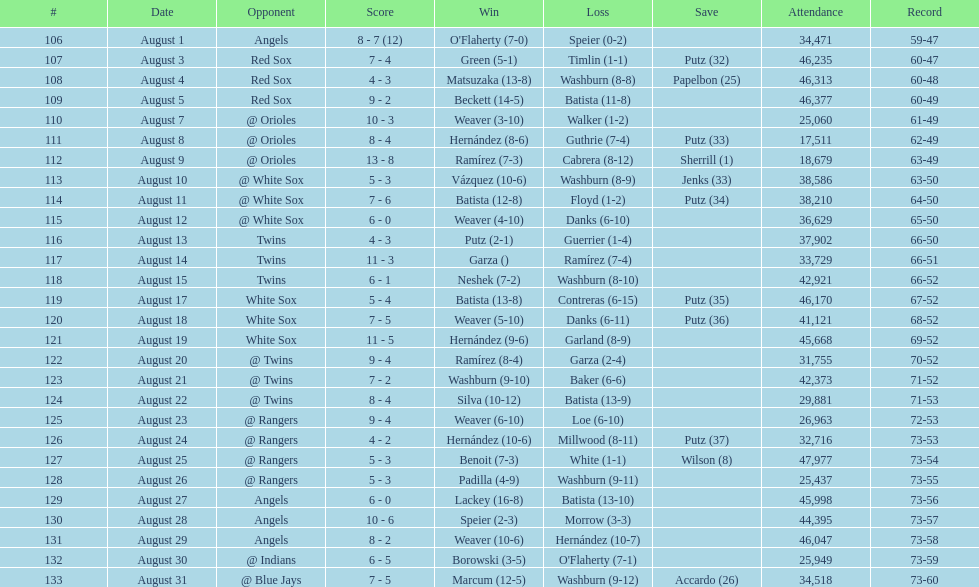Maximum run gap 8. Would you be able to parse every entry in this table? {'header': ['#', 'Date', 'Opponent', 'Score', 'Win', 'Loss', 'Save', 'Attendance', 'Record'], 'rows': [['106', 'August 1', 'Angels', '8 - 7 (12)', "O'Flaherty (7-0)", 'Speier (0-2)', '', '34,471', '59-47'], ['107', 'August 3', 'Red Sox', '7 - 4', 'Green (5-1)', 'Timlin (1-1)', 'Putz (32)', '46,235', '60-47'], ['108', 'August 4', 'Red Sox', '4 - 3', 'Matsuzaka (13-8)', 'Washburn (8-8)', 'Papelbon (25)', '46,313', '60-48'], ['109', 'August 5', 'Red Sox', '9 - 2', 'Beckett (14-5)', 'Batista (11-8)', '', '46,377', '60-49'], ['110', 'August 7', '@ Orioles', '10 - 3', 'Weaver (3-10)', 'Walker (1-2)', '', '25,060', '61-49'], ['111', 'August 8', '@ Orioles', '8 - 4', 'Hernández (8-6)', 'Guthrie (7-4)', 'Putz (33)', '17,511', '62-49'], ['112', 'August 9', '@ Orioles', '13 - 8', 'Ramírez (7-3)', 'Cabrera (8-12)', 'Sherrill (1)', '18,679', '63-49'], ['113', 'August 10', '@ White Sox', '5 - 3', 'Vázquez (10-6)', 'Washburn (8-9)', 'Jenks (33)', '38,586', '63-50'], ['114', 'August 11', '@ White Sox', '7 - 6', 'Batista (12-8)', 'Floyd (1-2)', 'Putz (34)', '38,210', '64-50'], ['115', 'August 12', '@ White Sox', '6 - 0', 'Weaver (4-10)', 'Danks (6-10)', '', '36,629', '65-50'], ['116', 'August 13', 'Twins', '4 - 3', 'Putz (2-1)', 'Guerrier (1-4)', '', '37,902', '66-50'], ['117', 'August 14', 'Twins', '11 - 3', 'Garza ()', 'Ramírez (7-4)', '', '33,729', '66-51'], ['118', 'August 15', 'Twins', '6 - 1', 'Neshek (7-2)', 'Washburn (8-10)', '', '42,921', '66-52'], ['119', 'August 17', 'White Sox', '5 - 4', 'Batista (13-8)', 'Contreras (6-15)', 'Putz (35)', '46,170', '67-52'], ['120', 'August 18', 'White Sox', '7 - 5', 'Weaver (5-10)', 'Danks (6-11)', 'Putz (36)', '41,121', '68-52'], ['121', 'August 19', 'White Sox', '11 - 5', 'Hernández (9-6)', 'Garland (8-9)', '', '45,668', '69-52'], ['122', 'August 20', '@ Twins', '9 - 4', 'Ramírez (8-4)', 'Garza (2-4)', '', '31,755', '70-52'], ['123', 'August 21', '@ Twins', '7 - 2', 'Washburn (9-10)', 'Baker (6-6)', '', '42,373', '71-52'], ['124', 'August 22', '@ Twins', '8 - 4', 'Silva (10-12)', 'Batista (13-9)', '', '29,881', '71-53'], ['125', 'August 23', '@ Rangers', '9 - 4', 'Weaver (6-10)', 'Loe (6-10)', '', '26,963', '72-53'], ['126', 'August 24', '@ Rangers', '4 - 2', 'Hernández (10-6)', 'Millwood (8-11)', 'Putz (37)', '32,716', '73-53'], ['127', 'August 25', '@ Rangers', '5 - 3', 'Benoit (7-3)', 'White (1-1)', 'Wilson (8)', '47,977', '73-54'], ['128', 'August 26', '@ Rangers', '5 - 3', 'Padilla (4-9)', 'Washburn (9-11)', '', '25,437', '73-55'], ['129', 'August 27', 'Angels', '6 - 0', 'Lackey (16-8)', 'Batista (13-10)', '', '45,998', '73-56'], ['130', 'August 28', 'Angels', '10 - 6', 'Speier (2-3)', 'Morrow (3-3)', '', '44,395', '73-57'], ['131', 'August 29', 'Angels', '8 - 2', 'Weaver (10-6)', 'Hernández (10-7)', '', '46,047', '73-58'], ['132', 'August 30', '@ Indians', '6 - 5', 'Borowski (3-5)', "O'Flaherty (7-1)", '', '25,949', '73-59'], ['133', 'August 31', '@ Blue Jays', '7 - 5', 'Marcum (12-5)', 'Washburn (9-12)', 'Accardo (26)', '34,518', '73-60']]} 